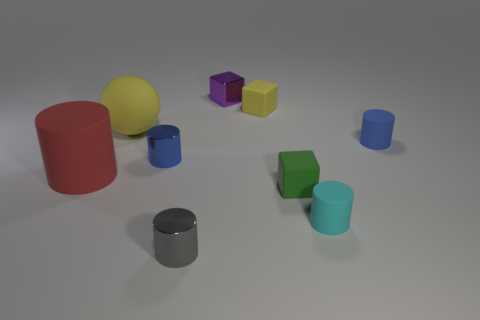There is a small blue thing that is to the right of the small rubber cube that is behind the big yellow thing; are there any tiny cubes that are on the right side of it?
Your response must be concise. No. Are there any other things that have the same material as the cyan thing?
Make the answer very short. Yes. There is a purple object that is made of the same material as the gray cylinder; what shape is it?
Offer a terse response. Cube. Is the number of blue metal cylinders to the right of the blue metallic cylinder less than the number of green objects to the left of the big cylinder?
Provide a short and direct response. No. What number of small things are either cyan metal spheres or red rubber cylinders?
Provide a succinct answer. 0. There is a large object that is behind the blue rubber thing; is it the same shape as the yellow matte thing that is to the right of the tiny purple block?
Your answer should be very brief. No. There is a yellow matte thing that is in front of the tiny matte block that is behind the cylinder that is on the left side of the yellow sphere; how big is it?
Offer a terse response. Large. There is a blue thing in front of the tiny blue matte thing; what is its size?
Offer a terse response. Small. What is the small yellow cube on the right side of the rubber sphere made of?
Provide a short and direct response. Rubber. What number of yellow things are either large cubes or blocks?
Offer a terse response. 1. 